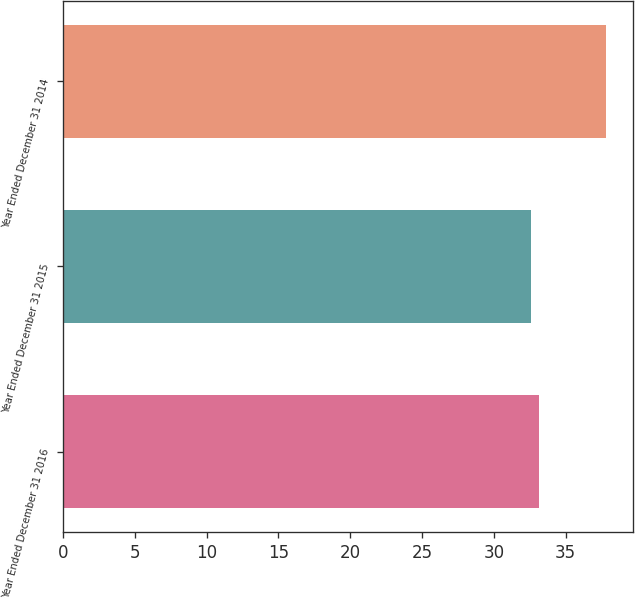Convert chart. <chart><loc_0><loc_0><loc_500><loc_500><bar_chart><fcel>Year Ended December 31 2016<fcel>Year Ended December 31 2015<fcel>Year Ended December 31 2014<nl><fcel>33.12<fcel>32.6<fcel>37.8<nl></chart> 